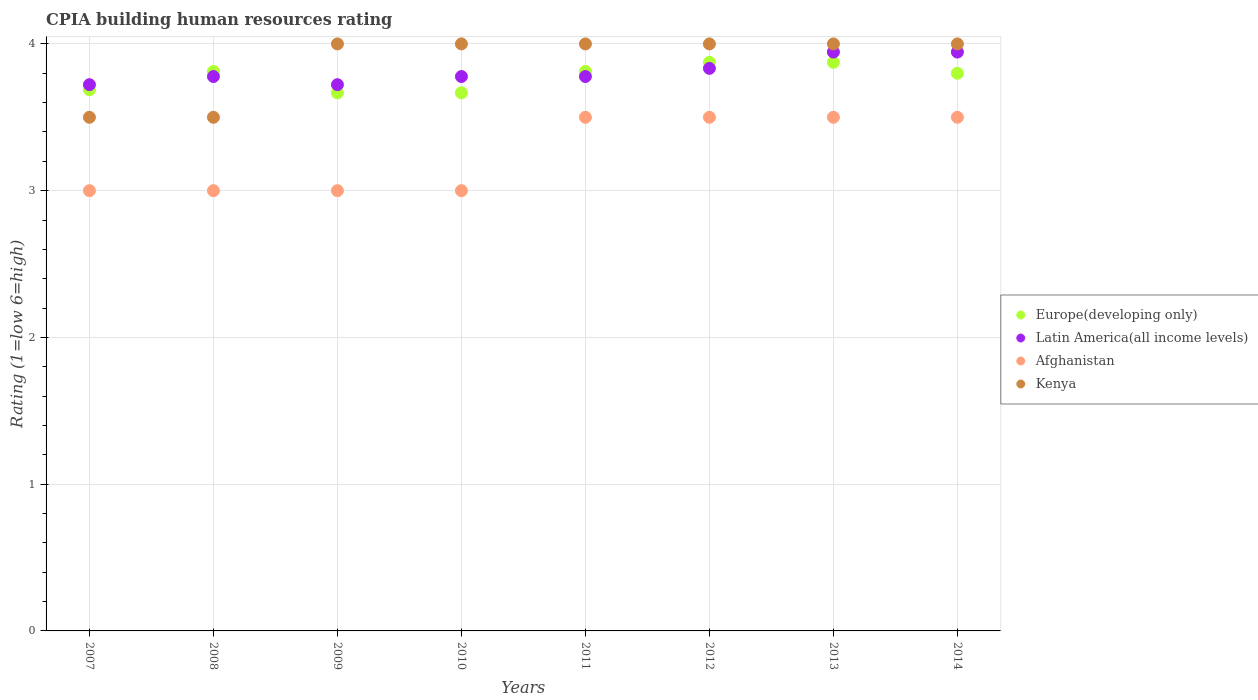Is the number of dotlines equal to the number of legend labels?
Provide a succinct answer. Yes. What is the CPIA rating in Afghanistan in 2010?
Make the answer very short. 3. Across all years, what is the maximum CPIA rating in Latin America(all income levels)?
Your response must be concise. 3.94. Across all years, what is the minimum CPIA rating in Latin America(all income levels)?
Make the answer very short. 3.72. What is the total CPIA rating in Afghanistan in the graph?
Provide a short and direct response. 26. What is the difference between the CPIA rating in Latin America(all income levels) in 2009 and that in 2014?
Give a very brief answer. -0.22. What is the difference between the CPIA rating in Latin America(all income levels) in 2010 and the CPIA rating in Kenya in 2012?
Ensure brevity in your answer.  -0.22. What is the average CPIA rating in Latin America(all income levels) per year?
Your answer should be very brief. 3.81. In the year 2010, what is the difference between the CPIA rating in Latin America(all income levels) and CPIA rating in Kenya?
Make the answer very short. -0.22. In how many years, is the CPIA rating in Europe(developing only) greater than 1.4?
Give a very brief answer. 8. Is the difference between the CPIA rating in Latin America(all income levels) in 2013 and 2014 greater than the difference between the CPIA rating in Kenya in 2013 and 2014?
Ensure brevity in your answer.  No. What is the difference between the highest and the second highest CPIA rating in Kenya?
Your answer should be compact. 0. What is the difference between the highest and the lowest CPIA rating in Kenya?
Your response must be concise. 0.5. Is the sum of the CPIA rating in Europe(developing only) in 2007 and 2013 greater than the maximum CPIA rating in Afghanistan across all years?
Provide a succinct answer. Yes. Is it the case that in every year, the sum of the CPIA rating in Latin America(all income levels) and CPIA rating in Kenya  is greater than the CPIA rating in Europe(developing only)?
Your answer should be compact. Yes. Does the CPIA rating in Europe(developing only) monotonically increase over the years?
Offer a terse response. No. How many dotlines are there?
Make the answer very short. 4. Are the values on the major ticks of Y-axis written in scientific E-notation?
Keep it short and to the point. No. Does the graph contain any zero values?
Your answer should be compact. No. Does the graph contain grids?
Make the answer very short. Yes. How are the legend labels stacked?
Give a very brief answer. Vertical. What is the title of the graph?
Make the answer very short. CPIA building human resources rating. Does "Italy" appear as one of the legend labels in the graph?
Make the answer very short. No. What is the label or title of the X-axis?
Your answer should be very brief. Years. What is the Rating (1=low 6=high) of Europe(developing only) in 2007?
Provide a short and direct response. 3.69. What is the Rating (1=low 6=high) of Latin America(all income levels) in 2007?
Ensure brevity in your answer.  3.72. What is the Rating (1=low 6=high) of Europe(developing only) in 2008?
Ensure brevity in your answer.  3.81. What is the Rating (1=low 6=high) in Latin America(all income levels) in 2008?
Provide a short and direct response. 3.78. What is the Rating (1=low 6=high) in Kenya in 2008?
Ensure brevity in your answer.  3.5. What is the Rating (1=low 6=high) of Europe(developing only) in 2009?
Your answer should be very brief. 3.67. What is the Rating (1=low 6=high) in Latin America(all income levels) in 2009?
Offer a terse response. 3.72. What is the Rating (1=low 6=high) of Afghanistan in 2009?
Make the answer very short. 3. What is the Rating (1=low 6=high) of Europe(developing only) in 2010?
Make the answer very short. 3.67. What is the Rating (1=low 6=high) of Latin America(all income levels) in 2010?
Offer a very short reply. 3.78. What is the Rating (1=low 6=high) in Kenya in 2010?
Offer a terse response. 4. What is the Rating (1=low 6=high) of Europe(developing only) in 2011?
Provide a succinct answer. 3.81. What is the Rating (1=low 6=high) in Latin America(all income levels) in 2011?
Your answer should be very brief. 3.78. What is the Rating (1=low 6=high) in Afghanistan in 2011?
Provide a short and direct response. 3.5. What is the Rating (1=low 6=high) of Kenya in 2011?
Provide a short and direct response. 4. What is the Rating (1=low 6=high) of Europe(developing only) in 2012?
Your answer should be compact. 3.88. What is the Rating (1=low 6=high) of Latin America(all income levels) in 2012?
Your answer should be compact. 3.83. What is the Rating (1=low 6=high) in Afghanistan in 2012?
Ensure brevity in your answer.  3.5. What is the Rating (1=low 6=high) in Europe(developing only) in 2013?
Ensure brevity in your answer.  3.88. What is the Rating (1=low 6=high) of Latin America(all income levels) in 2013?
Keep it short and to the point. 3.94. What is the Rating (1=low 6=high) of Afghanistan in 2013?
Keep it short and to the point. 3.5. What is the Rating (1=low 6=high) in Latin America(all income levels) in 2014?
Provide a short and direct response. 3.94. Across all years, what is the maximum Rating (1=low 6=high) in Europe(developing only)?
Provide a short and direct response. 3.88. Across all years, what is the maximum Rating (1=low 6=high) of Latin America(all income levels)?
Keep it short and to the point. 3.94. Across all years, what is the maximum Rating (1=low 6=high) of Afghanistan?
Ensure brevity in your answer.  3.5. Across all years, what is the minimum Rating (1=low 6=high) in Europe(developing only)?
Keep it short and to the point. 3.67. Across all years, what is the minimum Rating (1=low 6=high) of Latin America(all income levels)?
Provide a short and direct response. 3.72. Across all years, what is the minimum Rating (1=low 6=high) of Afghanistan?
Provide a succinct answer. 3. Across all years, what is the minimum Rating (1=low 6=high) of Kenya?
Keep it short and to the point. 3.5. What is the total Rating (1=low 6=high) in Europe(developing only) in the graph?
Make the answer very short. 30.2. What is the total Rating (1=low 6=high) of Latin America(all income levels) in the graph?
Make the answer very short. 30.5. What is the total Rating (1=low 6=high) of Afghanistan in the graph?
Provide a succinct answer. 26. What is the difference between the Rating (1=low 6=high) of Europe(developing only) in 2007 and that in 2008?
Your answer should be compact. -0.12. What is the difference between the Rating (1=low 6=high) in Latin America(all income levels) in 2007 and that in 2008?
Offer a very short reply. -0.06. What is the difference between the Rating (1=low 6=high) in Afghanistan in 2007 and that in 2008?
Offer a terse response. 0. What is the difference between the Rating (1=low 6=high) of Europe(developing only) in 2007 and that in 2009?
Provide a short and direct response. 0.02. What is the difference between the Rating (1=low 6=high) in Afghanistan in 2007 and that in 2009?
Provide a short and direct response. 0. What is the difference between the Rating (1=low 6=high) in Europe(developing only) in 2007 and that in 2010?
Make the answer very short. 0.02. What is the difference between the Rating (1=low 6=high) in Latin America(all income levels) in 2007 and that in 2010?
Offer a very short reply. -0.06. What is the difference between the Rating (1=low 6=high) of Afghanistan in 2007 and that in 2010?
Your answer should be compact. 0. What is the difference between the Rating (1=low 6=high) of Kenya in 2007 and that in 2010?
Your answer should be compact. -0.5. What is the difference between the Rating (1=low 6=high) in Europe(developing only) in 2007 and that in 2011?
Offer a very short reply. -0.12. What is the difference between the Rating (1=low 6=high) in Latin America(all income levels) in 2007 and that in 2011?
Keep it short and to the point. -0.06. What is the difference between the Rating (1=low 6=high) in Afghanistan in 2007 and that in 2011?
Your response must be concise. -0.5. What is the difference between the Rating (1=low 6=high) of Europe(developing only) in 2007 and that in 2012?
Keep it short and to the point. -0.19. What is the difference between the Rating (1=low 6=high) of Latin America(all income levels) in 2007 and that in 2012?
Your answer should be compact. -0.11. What is the difference between the Rating (1=low 6=high) of Afghanistan in 2007 and that in 2012?
Give a very brief answer. -0.5. What is the difference between the Rating (1=low 6=high) in Europe(developing only) in 2007 and that in 2013?
Keep it short and to the point. -0.19. What is the difference between the Rating (1=low 6=high) of Latin America(all income levels) in 2007 and that in 2013?
Provide a short and direct response. -0.22. What is the difference between the Rating (1=low 6=high) in Afghanistan in 2007 and that in 2013?
Offer a terse response. -0.5. What is the difference between the Rating (1=low 6=high) in Europe(developing only) in 2007 and that in 2014?
Your answer should be very brief. -0.11. What is the difference between the Rating (1=low 6=high) in Latin America(all income levels) in 2007 and that in 2014?
Offer a very short reply. -0.22. What is the difference between the Rating (1=low 6=high) in Afghanistan in 2007 and that in 2014?
Provide a succinct answer. -0.5. What is the difference between the Rating (1=low 6=high) of Kenya in 2007 and that in 2014?
Offer a very short reply. -0.5. What is the difference between the Rating (1=low 6=high) of Europe(developing only) in 2008 and that in 2009?
Your answer should be very brief. 0.15. What is the difference between the Rating (1=low 6=high) of Latin America(all income levels) in 2008 and that in 2009?
Provide a short and direct response. 0.06. What is the difference between the Rating (1=low 6=high) in Kenya in 2008 and that in 2009?
Offer a very short reply. -0.5. What is the difference between the Rating (1=low 6=high) in Europe(developing only) in 2008 and that in 2010?
Ensure brevity in your answer.  0.15. What is the difference between the Rating (1=low 6=high) of Kenya in 2008 and that in 2010?
Provide a short and direct response. -0.5. What is the difference between the Rating (1=low 6=high) in Afghanistan in 2008 and that in 2011?
Keep it short and to the point. -0.5. What is the difference between the Rating (1=low 6=high) of Kenya in 2008 and that in 2011?
Your answer should be very brief. -0.5. What is the difference between the Rating (1=low 6=high) of Europe(developing only) in 2008 and that in 2012?
Offer a very short reply. -0.06. What is the difference between the Rating (1=low 6=high) in Latin America(all income levels) in 2008 and that in 2012?
Keep it short and to the point. -0.06. What is the difference between the Rating (1=low 6=high) of Kenya in 2008 and that in 2012?
Give a very brief answer. -0.5. What is the difference between the Rating (1=low 6=high) of Europe(developing only) in 2008 and that in 2013?
Keep it short and to the point. -0.06. What is the difference between the Rating (1=low 6=high) of Kenya in 2008 and that in 2013?
Keep it short and to the point. -0.5. What is the difference between the Rating (1=low 6=high) in Europe(developing only) in 2008 and that in 2014?
Keep it short and to the point. 0.01. What is the difference between the Rating (1=low 6=high) in Latin America(all income levels) in 2008 and that in 2014?
Your response must be concise. -0.17. What is the difference between the Rating (1=low 6=high) of Kenya in 2008 and that in 2014?
Your answer should be very brief. -0.5. What is the difference between the Rating (1=low 6=high) in Latin America(all income levels) in 2009 and that in 2010?
Offer a terse response. -0.06. What is the difference between the Rating (1=low 6=high) in Afghanistan in 2009 and that in 2010?
Provide a short and direct response. 0. What is the difference between the Rating (1=low 6=high) of Kenya in 2009 and that in 2010?
Give a very brief answer. 0. What is the difference between the Rating (1=low 6=high) in Europe(developing only) in 2009 and that in 2011?
Give a very brief answer. -0.15. What is the difference between the Rating (1=low 6=high) of Latin America(all income levels) in 2009 and that in 2011?
Keep it short and to the point. -0.06. What is the difference between the Rating (1=low 6=high) of Kenya in 2009 and that in 2011?
Provide a short and direct response. 0. What is the difference between the Rating (1=low 6=high) in Europe(developing only) in 2009 and that in 2012?
Your answer should be very brief. -0.21. What is the difference between the Rating (1=low 6=high) of Latin America(all income levels) in 2009 and that in 2012?
Provide a short and direct response. -0.11. What is the difference between the Rating (1=low 6=high) of Afghanistan in 2009 and that in 2012?
Offer a terse response. -0.5. What is the difference between the Rating (1=low 6=high) in Kenya in 2009 and that in 2012?
Provide a succinct answer. 0. What is the difference between the Rating (1=low 6=high) in Europe(developing only) in 2009 and that in 2013?
Offer a terse response. -0.21. What is the difference between the Rating (1=low 6=high) of Latin America(all income levels) in 2009 and that in 2013?
Make the answer very short. -0.22. What is the difference between the Rating (1=low 6=high) in Afghanistan in 2009 and that in 2013?
Keep it short and to the point. -0.5. What is the difference between the Rating (1=low 6=high) of Kenya in 2009 and that in 2013?
Offer a terse response. 0. What is the difference between the Rating (1=low 6=high) of Europe(developing only) in 2009 and that in 2014?
Make the answer very short. -0.13. What is the difference between the Rating (1=low 6=high) in Latin America(all income levels) in 2009 and that in 2014?
Offer a very short reply. -0.22. What is the difference between the Rating (1=low 6=high) in Kenya in 2009 and that in 2014?
Ensure brevity in your answer.  0. What is the difference between the Rating (1=low 6=high) of Europe(developing only) in 2010 and that in 2011?
Make the answer very short. -0.15. What is the difference between the Rating (1=low 6=high) in Latin America(all income levels) in 2010 and that in 2011?
Make the answer very short. 0. What is the difference between the Rating (1=low 6=high) in Afghanistan in 2010 and that in 2011?
Your answer should be very brief. -0.5. What is the difference between the Rating (1=low 6=high) in Europe(developing only) in 2010 and that in 2012?
Offer a very short reply. -0.21. What is the difference between the Rating (1=low 6=high) of Latin America(all income levels) in 2010 and that in 2012?
Ensure brevity in your answer.  -0.06. What is the difference between the Rating (1=low 6=high) of Europe(developing only) in 2010 and that in 2013?
Give a very brief answer. -0.21. What is the difference between the Rating (1=low 6=high) in Latin America(all income levels) in 2010 and that in 2013?
Offer a very short reply. -0.17. What is the difference between the Rating (1=low 6=high) of Afghanistan in 2010 and that in 2013?
Make the answer very short. -0.5. What is the difference between the Rating (1=low 6=high) in Europe(developing only) in 2010 and that in 2014?
Ensure brevity in your answer.  -0.13. What is the difference between the Rating (1=low 6=high) of Kenya in 2010 and that in 2014?
Ensure brevity in your answer.  0. What is the difference between the Rating (1=low 6=high) of Europe(developing only) in 2011 and that in 2012?
Keep it short and to the point. -0.06. What is the difference between the Rating (1=low 6=high) of Latin America(all income levels) in 2011 and that in 2012?
Provide a short and direct response. -0.06. What is the difference between the Rating (1=low 6=high) of Kenya in 2011 and that in 2012?
Give a very brief answer. 0. What is the difference between the Rating (1=low 6=high) in Europe(developing only) in 2011 and that in 2013?
Provide a succinct answer. -0.06. What is the difference between the Rating (1=low 6=high) of Afghanistan in 2011 and that in 2013?
Make the answer very short. 0. What is the difference between the Rating (1=low 6=high) of Kenya in 2011 and that in 2013?
Make the answer very short. 0. What is the difference between the Rating (1=low 6=high) in Europe(developing only) in 2011 and that in 2014?
Provide a succinct answer. 0.01. What is the difference between the Rating (1=low 6=high) of Kenya in 2011 and that in 2014?
Your answer should be compact. 0. What is the difference between the Rating (1=low 6=high) in Europe(developing only) in 2012 and that in 2013?
Ensure brevity in your answer.  0. What is the difference between the Rating (1=low 6=high) in Latin America(all income levels) in 2012 and that in 2013?
Provide a short and direct response. -0.11. What is the difference between the Rating (1=low 6=high) in Afghanistan in 2012 and that in 2013?
Keep it short and to the point. 0. What is the difference between the Rating (1=low 6=high) of Kenya in 2012 and that in 2013?
Offer a terse response. 0. What is the difference between the Rating (1=low 6=high) of Europe(developing only) in 2012 and that in 2014?
Ensure brevity in your answer.  0.07. What is the difference between the Rating (1=low 6=high) of Latin America(all income levels) in 2012 and that in 2014?
Keep it short and to the point. -0.11. What is the difference between the Rating (1=low 6=high) of Afghanistan in 2012 and that in 2014?
Make the answer very short. 0. What is the difference between the Rating (1=low 6=high) of Europe(developing only) in 2013 and that in 2014?
Offer a very short reply. 0.07. What is the difference between the Rating (1=low 6=high) in Afghanistan in 2013 and that in 2014?
Offer a terse response. 0. What is the difference between the Rating (1=low 6=high) of Kenya in 2013 and that in 2014?
Offer a very short reply. 0. What is the difference between the Rating (1=low 6=high) in Europe(developing only) in 2007 and the Rating (1=low 6=high) in Latin America(all income levels) in 2008?
Provide a succinct answer. -0.09. What is the difference between the Rating (1=low 6=high) in Europe(developing only) in 2007 and the Rating (1=low 6=high) in Afghanistan in 2008?
Make the answer very short. 0.69. What is the difference between the Rating (1=low 6=high) in Europe(developing only) in 2007 and the Rating (1=low 6=high) in Kenya in 2008?
Your answer should be very brief. 0.19. What is the difference between the Rating (1=low 6=high) of Latin America(all income levels) in 2007 and the Rating (1=low 6=high) of Afghanistan in 2008?
Offer a very short reply. 0.72. What is the difference between the Rating (1=low 6=high) of Latin America(all income levels) in 2007 and the Rating (1=low 6=high) of Kenya in 2008?
Give a very brief answer. 0.22. What is the difference between the Rating (1=low 6=high) of Europe(developing only) in 2007 and the Rating (1=low 6=high) of Latin America(all income levels) in 2009?
Offer a very short reply. -0.03. What is the difference between the Rating (1=low 6=high) in Europe(developing only) in 2007 and the Rating (1=low 6=high) in Afghanistan in 2009?
Provide a short and direct response. 0.69. What is the difference between the Rating (1=low 6=high) of Europe(developing only) in 2007 and the Rating (1=low 6=high) of Kenya in 2009?
Keep it short and to the point. -0.31. What is the difference between the Rating (1=low 6=high) in Latin America(all income levels) in 2007 and the Rating (1=low 6=high) in Afghanistan in 2009?
Keep it short and to the point. 0.72. What is the difference between the Rating (1=low 6=high) of Latin America(all income levels) in 2007 and the Rating (1=low 6=high) of Kenya in 2009?
Provide a succinct answer. -0.28. What is the difference between the Rating (1=low 6=high) in Europe(developing only) in 2007 and the Rating (1=low 6=high) in Latin America(all income levels) in 2010?
Your answer should be compact. -0.09. What is the difference between the Rating (1=low 6=high) in Europe(developing only) in 2007 and the Rating (1=low 6=high) in Afghanistan in 2010?
Offer a terse response. 0.69. What is the difference between the Rating (1=low 6=high) of Europe(developing only) in 2007 and the Rating (1=low 6=high) of Kenya in 2010?
Your answer should be very brief. -0.31. What is the difference between the Rating (1=low 6=high) of Latin America(all income levels) in 2007 and the Rating (1=low 6=high) of Afghanistan in 2010?
Provide a short and direct response. 0.72. What is the difference between the Rating (1=low 6=high) of Latin America(all income levels) in 2007 and the Rating (1=low 6=high) of Kenya in 2010?
Keep it short and to the point. -0.28. What is the difference between the Rating (1=low 6=high) in Afghanistan in 2007 and the Rating (1=low 6=high) in Kenya in 2010?
Offer a terse response. -1. What is the difference between the Rating (1=low 6=high) of Europe(developing only) in 2007 and the Rating (1=low 6=high) of Latin America(all income levels) in 2011?
Keep it short and to the point. -0.09. What is the difference between the Rating (1=low 6=high) of Europe(developing only) in 2007 and the Rating (1=low 6=high) of Afghanistan in 2011?
Provide a succinct answer. 0.19. What is the difference between the Rating (1=low 6=high) in Europe(developing only) in 2007 and the Rating (1=low 6=high) in Kenya in 2011?
Give a very brief answer. -0.31. What is the difference between the Rating (1=low 6=high) of Latin America(all income levels) in 2007 and the Rating (1=low 6=high) of Afghanistan in 2011?
Ensure brevity in your answer.  0.22. What is the difference between the Rating (1=low 6=high) in Latin America(all income levels) in 2007 and the Rating (1=low 6=high) in Kenya in 2011?
Give a very brief answer. -0.28. What is the difference between the Rating (1=low 6=high) in Europe(developing only) in 2007 and the Rating (1=low 6=high) in Latin America(all income levels) in 2012?
Your answer should be compact. -0.15. What is the difference between the Rating (1=low 6=high) of Europe(developing only) in 2007 and the Rating (1=low 6=high) of Afghanistan in 2012?
Offer a very short reply. 0.19. What is the difference between the Rating (1=low 6=high) in Europe(developing only) in 2007 and the Rating (1=low 6=high) in Kenya in 2012?
Your response must be concise. -0.31. What is the difference between the Rating (1=low 6=high) in Latin America(all income levels) in 2007 and the Rating (1=low 6=high) in Afghanistan in 2012?
Your response must be concise. 0.22. What is the difference between the Rating (1=low 6=high) of Latin America(all income levels) in 2007 and the Rating (1=low 6=high) of Kenya in 2012?
Your response must be concise. -0.28. What is the difference between the Rating (1=low 6=high) of Afghanistan in 2007 and the Rating (1=low 6=high) of Kenya in 2012?
Offer a very short reply. -1. What is the difference between the Rating (1=low 6=high) of Europe(developing only) in 2007 and the Rating (1=low 6=high) of Latin America(all income levels) in 2013?
Provide a short and direct response. -0.26. What is the difference between the Rating (1=low 6=high) in Europe(developing only) in 2007 and the Rating (1=low 6=high) in Afghanistan in 2013?
Offer a very short reply. 0.19. What is the difference between the Rating (1=low 6=high) in Europe(developing only) in 2007 and the Rating (1=low 6=high) in Kenya in 2013?
Your response must be concise. -0.31. What is the difference between the Rating (1=low 6=high) in Latin America(all income levels) in 2007 and the Rating (1=low 6=high) in Afghanistan in 2013?
Provide a short and direct response. 0.22. What is the difference between the Rating (1=low 6=high) in Latin America(all income levels) in 2007 and the Rating (1=low 6=high) in Kenya in 2013?
Keep it short and to the point. -0.28. What is the difference between the Rating (1=low 6=high) of Europe(developing only) in 2007 and the Rating (1=low 6=high) of Latin America(all income levels) in 2014?
Provide a short and direct response. -0.26. What is the difference between the Rating (1=low 6=high) in Europe(developing only) in 2007 and the Rating (1=low 6=high) in Afghanistan in 2014?
Provide a succinct answer. 0.19. What is the difference between the Rating (1=low 6=high) in Europe(developing only) in 2007 and the Rating (1=low 6=high) in Kenya in 2014?
Your answer should be very brief. -0.31. What is the difference between the Rating (1=low 6=high) in Latin America(all income levels) in 2007 and the Rating (1=low 6=high) in Afghanistan in 2014?
Make the answer very short. 0.22. What is the difference between the Rating (1=low 6=high) in Latin America(all income levels) in 2007 and the Rating (1=low 6=high) in Kenya in 2014?
Make the answer very short. -0.28. What is the difference between the Rating (1=low 6=high) in Europe(developing only) in 2008 and the Rating (1=low 6=high) in Latin America(all income levels) in 2009?
Make the answer very short. 0.09. What is the difference between the Rating (1=low 6=high) in Europe(developing only) in 2008 and the Rating (1=low 6=high) in Afghanistan in 2009?
Make the answer very short. 0.81. What is the difference between the Rating (1=low 6=high) of Europe(developing only) in 2008 and the Rating (1=low 6=high) of Kenya in 2009?
Your response must be concise. -0.19. What is the difference between the Rating (1=low 6=high) of Latin America(all income levels) in 2008 and the Rating (1=low 6=high) of Afghanistan in 2009?
Provide a short and direct response. 0.78. What is the difference between the Rating (1=low 6=high) of Latin America(all income levels) in 2008 and the Rating (1=low 6=high) of Kenya in 2009?
Give a very brief answer. -0.22. What is the difference between the Rating (1=low 6=high) of Afghanistan in 2008 and the Rating (1=low 6=high) of Kenya in 2009?
Give a very brief answer. -1. What is the difference between the Rating (1=low 6=high) in Europe(developing only) in 2008 and the Rating (1=low 6=high) in Latin America(all income levels) in 2010?
Your answer should be compact. 0.03. What is the difference between the Rating (1=low 6=high) in Europe(developing only) in 2008 and the Rating (1=low 6=high) in Afghanistan in 2010?
Provide a short and direct response. 0.81. What is the difference between the Rating (1=low 6=high) in Europe(developing only) in 2008 and the Rating (1=low 6=high) in Kenya in 2010?
Your response must be concise. -0.19. What is the difference between the Rating (1=low 6=high) in Latin America(all income levels) in 2008 and the Rating (1=low 6=high) in Afghanistan in 2010?
Give a very brief answer. 0.78. What is the difference between the Rating (1=low 6=high) of Latin America(all income levels) in 2008 and the Rating (1=low 6=high) of Kenya in 2010?
Your answer should be compact. -0.22. What is the difference between the Rating (1=low 6=high) in Europe(developing only) in 2008 and the Rating (1=low 6=high) in Latin America(all income levels) in 2011?
Give a very brief answer. 0.03. What is the difference between the Rating (1=low 6=high) in Europe(developing only) in 2008 and the Rating (1=low 6=high) in Afghanistan in 2011?
Provide a short and direct response. 0.31. What is the difference between the Rating (1=low 6=high) of Europe(developing only) in 2008 and the Rating (1=low 6=high) of Kenya in 2011?
Keep it short and to the point. -0.19. What is the difference between the Rating (1=low 6=high) of Latin America(all income levels) in 2008 and the Rating (1=low 6=high) of Afghanistan in 2011?
Give a very brief answer. 0.28. What is the difference between the Rating (1=low 6=high) in Latin America(all income levels) in 2008 and the Rating (1=low 6=high) in Kenya in 2011?
Ensure brevity in your answer.  -0.22. What is the difference between the Rating (1=low 6=high) in Afghanistan in 2008 and the Rating (1=low 6=high) in Kenya in 2011?
Provide a succinct answer. -1. What is the difference between the Rating (1=low 6=high) of Europe(developing only) in 2008 and the Rating (1=low 6=high) of Latin America(all income levels) in 2012?
Provide a succinct answer. -0.02. What is the difference between the Rating (1=low 6=high) in Europe(developing only) in 2008 and the Rating (1=low 6=high) in Afghanistan in 2012?
Your answer should be compact. 0.31. What is the difference between the Rating (1=low 6=high) in Europe(developing only) in 2008 and the Rating (1=low 6=high) in Kenya in 2012?
Your answer should be very brief. -0.19. What is the difference between the Rating (1=low 6=high) of Latin America(all income levels) in 2008 and the Rating (1=low 6=high) of Afghanistan in 2012?
Make the answer very short. 0.28. What is the difference between the Rating (1=low 6=high) in Latin America(all income levels) in 2008 and the Rating (1=low 6=high) in Kenya in 2012?
Keep it short and to the point. -0.22. What is the difference between the Rating (1=low 6=high) of Afghanistan in 2008 and the Rating (1=low 6=high) of Kenya in 2012?
Make the answer very short. -1. What is the difference between the Rating (1=low 6=high) in Europe(developing only) in 2008 and the Rating (1=low 6=high) in Latin America(all income levels) in 2013?
Your answer should be compact. -0.13. What is the difference between the Rating (1=low 6=high) of Europe(developing only) in 2008 and the Rating (1=low 6=high) of Afghanistan in 2013?
Your answer should be compact. 0.31. What is the difference between the Rating (1=low 6=high) in Europe(developing only) in 2008 and the Rating (1=low 6=high) in Kenya in 2013?
Provide a succinct answer. -0.19. What is the difference between the Rating (1=low 6=high) in Latin America(all income levels) in 2008 and the Rating (1=low 6=high) in Afghanistan in 2013?
Your answer should be very brief. 0.28. What is the difference between the Rating (1=low 6=high) of Latin America(all income levels) in 2008 and the Rating (1=low 6=high) of Kenya in 2013?
Offer a terse response. -0.22. What is the difference between the Rating (1=low 6=high) of Afghanistan in 2008 and the Rating (1=low 6=high) of Kenya in 2013?
Give a very brief answer. -1. What is the difference between the Rating (1=low 6=high) in Europe(developing only) in 2008 and the Rating (1=low 6=high) in Latin America(all income levels) in 2014?
Your answer should be compact. -0.13. What is the difference between the Rating (1=low 6=high) of Europe(developing only) in 2008 and the Rating (1=low 6=high) of Afghanistan in 2014?
Keep it short and to the point. 0.31. What is the difference between the Rating (1=low 6=high) of Europe(developing only) in 2008 and the Rating (1=low 6=high) of Kenya in 2014?
Ensure brevity in your answer.  -0.19. What is the difference between the Rating (1=low 6=high) in Latin America(all income levels) in 2008 and the Rating (1=low 6=high) in Afghanistan in 2014?
Provide a succinct answer. 0.28. What is the difference between the Rating (1=low 6=high) of Latin America(all income levels) in 2008 and the Rating (1=low 6=high) of Kenya in 2014?
Keep it short and to the point. -0.22. What is the difference between the Rating (1=low 6=high) in Europe(developing only) in 2009 and the Rating (1=low 6=high) in Latin America(all income levels) in 2010?
Make the answer very short. -0.11. What is the difference between the Rating (1=low 6=high) in Latin America(all income levels) in 2009 and the Rating (1=low 6=high) in Afghanistan in 2010?
Offer a terse response. 0.72. What is the difference between the Rating (1=low 6=high) of Latin America(all income levels) in 2009 and the Rating (1=low 6=high) of Kenya in 2010?
Ensure brevity in your answer.  -0.28. What is the difference between the Rating (1=low 6=high) of Europe(developing only) in 2009 and the Rating (1=low 6=high) of Latin America(all income levels) in 2011?
Your answer should be compact. -0.11. What is the difference between the Rating (1=low 6=high) of Europe(developing only) in 2009 and the Rating (1=low 6=high) of Afghanistan in 2011?
Your answer should be very brief. 0.17. What is the difference between the Rating (1=low 6=high) of Latin America(all income levels) in 2009 and the Rating (1=low 6=high) of Afghanistan in 2011?
Your answer should be very brief. 0.22. What is the difference between the Rating (1=low 6=high) in Latin America(all income levels) in 2009 and the Rating (1=low 6=high) in Kenya in 2011?
Keep it short and to the point. -0.28. What is the difference between the Rating (1=low 6=high) of Europe(developing only) in 2009 and the Rating (1=low 6=high) of Latin America(all income levels) in 2012?
Provide a short and direct response. -0.17. What is the difference between the Rating (1=low 6=high) of Europe(developing only) in 2009 and the Rating (1=low 6=high) of Kenya in 2012?
Keep it short and to the point. -0.33. What is the difference between the Rating (1=low 6=high) in Latin America(all income levels) in 2009 and the Rating (1=low 6=high) in Afghanistan in 2012?
Provide a short and direct response. 0.22. What is the difference between the Rating (1=low 6=high) of Latin America(all income levels) in 2009 and the Rating (1=low 6=high) of Kenya in 2012?
Give a very brief answer. -0.28. What is the difference between the Rating (1=low 6=high) in Afghanistan in 2009 and the Rating (1=low 6=high) in Kenya in 2012?
Offer a terse response. -1. What is the difference between the Rating (1=low 6=high) of Europe(developing only) in 2009 and the Rating (1=low 6=high) of Latin America(all income levels) in 2013?
Provide a short and direct response. -0.28. What is the difference between the Rating (1=low 6=high) in Europe(developing only) in 2009 and the Rating (1=low 6=high) in Kenya in 2013?
Your response must be concise. -0.33. What is the difference between the Rating (1=low 6=high) of Latin America(all income levels) in 2009 and the Rating (1=low 6=high) of Afghanistan in 2013?
Provide a short and direct response. 0.22. What is the difference between the Rating (1=low 6=high) in Latin America(all income levels) in 2009 and the Rating (1=low 6=high) in Kenya in 2013?
Provide a short and direct response. -0.28. What is the difference between the Rating (1=low 6=high) of Afghanistan in 2009 and the Rating (1=low 6=high) of Kenya in 2013?
Provide a succinct answer. -1. What is the difference between the Rating (1=low 6=high) of Europe(developing only) in 2009 and the Rating (1=low 6=high) of Latin America(all income levels) in 2014?
Give a very brief answer. -0.28. What is the difference between the Rating (1=low 6=high) of Latin America(all income levels) in 2009 and the Rating (1=low 6=high) of Afghanistan in 2014?
Provide a short and direct response. 0.22. What is the difference between the Rating (1=low 6=high) in Latin America(all income levels) in 2009 and the Rating (1=low 6=high) in Kenya in 2014?
Offer a very short reply. -0.28. What is the difference between the Rating (1=low 6=high) of Afghanistan in 2009 and the Rating (1=low 6=high) of Kenya in 2014?
Your response must be concise. -1. What is the difference between the Rating (1=low 6=high) of Europe(developing only) in 2010 and the Rating (1=low 6=high) of Latin America(all income levels) in 2011?
Make the answer very short. -0.11. What is the difference between the Rating (1=low 6=high) of Europe(developing only) in 2010 and the Rating (1=low 6=high) of Afghanistan in 2011?
Make the answer very short. 0.17. What is the difference between the Rating (1=low 6=high) in Latin America(all income levels) in 2010 and the Rating (1=low 6=high) in Afghanistan in 2011?
Offer a terse response. 0.28. What is the difference between the Rating (1=low 6=high) in Latin America(all income levels) in 2010 and the Rating (1=low 6=high) in Kenya in 2011?
Provide a short and direct response. -0.22. What is the difference between the Rating (1=low 6=high) in Afghanistan in 2010 and the Rating (1=low 6=high) in Kenya in 2011?
Offer a very short reply. -1. What is the difference between the Rating (1=low 6=high) of Europe(developing only) in 2010 and the Rating (1=low 6=high) of Kenya in 2012?
Offer a very short reply. -0.33. What is the difference between the Rating (1=low 6=high) in Latin America(all income levels) in 2010 and the Rating (1=low 6=high) in Afghanistan in 2012?
Provide a succinct answer. 0.28. What is the difference between the Rating (1=low 6=high) in Latin America(all income levels) in 2010 and the Rating (1=low 6=high) in Kenya in 2012?
Offer a very short reply. -0.22. What is the difference between the Rating (1=low 6=high) in Afghanistan in 2010 and the Rating (1=low 6=high) in Kenya in 2012?
Offer a very short reply. -1. What is the difference between the Rating (1=low 6=high) in Europe(developing only) in 2010 and the Rating (1=low 6=high) in Latin America(all income levels) in 2013?
Give a very brief answer. -0.28. What is the difference between the Rating (1=low 6=high) in Latin America(all income levels) in 2010 and the Rating (1=low 6=high) in Afghanistan in 2013?
Provide a succinct answer. 0.28. What is the difference between the Rating (1=low 6=high) of Latin America(all income levels) in 2010 and the Rating (1=low 6=high) of Kenya in 2013?
Offer a terse response. -0.22. What is the difference between the Rating (1=low 6=high) of Afghanistan in 2010 and the Rating (1=low 6=high) of Kenya in 2013?
Ensure brevity in your answer.  -1. What is the difference between the Rating (1=low 6=high) of Europe(developing only) in 2010 and the Rating (1=low 6=high) of Latin America(all income levels) in 2014?
Your answer should be very brief. -0.28. What is the difference between the Rating (1=low 6=high) in Europe(developing only) in 2010 and the Rating (1=low 6=high) in Afghanistan in 2014?
Provide a succinct answer. 0.17. What is the difference between the Rating (1=low 6=high) of Europe(developing only) in 2010 and the Rating (1=low 6=high) of Kenya in 2014?
Give a very brief answer. -0.33. What is the difference between the Rating (1=low 6=high) of Latin America(all income levels) in 2010 and the Rating (1=low 6=high) of Afghanistan in 2014?
Offer a terse response. 0.28. What is the difference between the Rating (1=low 6=high) in Latin America(all income levels) in 2010 and the Rating (1=low 6=high) in Kenya in 2014?
Make the answer very short. -0.22. What is the difference between the Rating (1=low 6=high) of Afghanistan in 2010 and the Rating (1=low 6=high) of Kenya in 2014?
Offer a terse response. -1. What is the difference between the Rating (1=low 6=high) of Europe(developing only) in 2011 and the Rating (1=low 6=high) of Latin America(all income levels) in 2012?
Provide a succinct answer. -0.02. What is the difference between the Rating (1=low 6=high) of Europe(developing only) in 2011 and the Rating (1=low 6=high) of Afghanistan in 2012?
Your answer should be very brief. 0.31. What is the difference between the Rating (1=low 6=high) of Europe(developing only) in 2011 and the Rating (1=low 6=high) of Kenya in 2012?
Provide a short and direct response. -0.19. What is the difference between the Rating (1=low 6=high) in Latin America(all income levels) in 2011 and the Rating (1=low 6=high) in Afghanistan in 2012?
Your answer should be very brief. 0.28. What is the difference between the Rating (1=low 6=high) in Latin America(all income levels) in 2011 and the Rating (1=low 6=high) in Kenya in 2012?
Offer a very short reply. -0.22. What is the difference between the Rating (1=low 6=high) of Europe(developing only) in 2011 and the Rating (1=low 6=high) of Latin America(all income levels) in 2013?
Keep it short and to the point. -0.13. What is the difference between the Rating (1=low 6=high) in Europe(developing only) in 2011 and the Rating (1=low 6=high) in Afghanistan in 2013?
Ensure brevity in your answer.  0.31. What is the difference between the Rating (1=low 6=high) in Europe(developing only) in 2011 and the Rating (1=low 6=high) in Kenya in 2013?
Provide a short and direct response. -0.19. What is the difference between the Rating (1=low 6=high) in Latin America(all income levels) in 2011 and the Rating (1=low 6=high) in Afghanistan in 2013?
Ensure brevity in your answer.  0.28. What is the difference between the Rating (1=low 6=high) in Latin America(all income levels) in 2011 and the Rating (1=low 6=high) in Kenya in 2013?
Keep it short and to the point. -0.22. What is the difference between the Rating (1=low 6=high) in Afghanistan in 2011 and the Rating (1=low 6=high) in Kenya in 2013?
Offer a terse response. -0.5. What is the difference between the Rating (1=low 6=high) in Europe(developing only) in 2011 and the Rating (1=low 6=high) in Latin America(all income levels) in 2014?
Offer a very short reply. -0.13. What is the difference between the Rating (1=low 6=high) of Europe(developing only) in 2011 and the Rating (1=low 6=high) of Afghanistan in 2014?
Offer a terse response. 0.31. What is the difference between the Rating (1=low 6=high) in Europe(developing only) in 2011 and the Rating (1=low 6=high) in Kenya in 2014?
Offer a very short reply. -0.19. What is the difference between the Rating (1=low 6=high) in Latin America(all income levels) in 2011 and the Rating (1=low 6=high) in Afghanistan in 2014?
Keep it short and to the point. 0.28. What is the difference between the Rating (1=low 6=high) in Latin America(all income levels) in 2011 and the Rating (1=low 6=high) in Kenya in 2014?
Your answer should be very brief. -0.22. What is the difference between the Rating (1=low 6=high) of Afghanistan in 2011 and the Rating (1=low 6=high) of Kenya in 2014?
Give a very brief answer. -0.5. What is the difference between the Rating (1=low 6=high) in Europe(developing only) in 2012 and the Rating (1=low 6=high) in Latin America(all income levels) in 2013?
Provide a short and direct response. -0.07. What is the difference between the Rating (1=low 6=high) in Europe(developing only) in 2012 and the Rating (1=low 6=high) in Kenya in 2013?
Your response must be concise. -0.12. What is the difference between the Rating (1=low 6=high) in Latin America(all income levels) in 2012 and the Rating (1=low 6=high) in Kenya in 2013?
Provide a succinct answer. -0.17. What is the difference between the Rating (1=low 6=high) in Europe(developing only) in 2012 and the Rating (1=low 6=high) in Latin America(all income levels) in 2014?
Your answer should be very brief. -0.07. What is the difference between the Rating (1=low 6=high) of Europe(developing only) in 2012 and the Rating (1=low 6=high) of Kenya in 2014?
Ensure brevity in your answer.  -0.12. What is the difference between the Rating (1=low 6=high) of Latin America(all income levels) in 2012 and the Rating (1=low 6=high) of Afghanistan in 2014?
Provide a short and direct response. 0.33. What is the difference between the Rating (1=low 6=high) in Afghanistan in 2012 and the Rating (1=low 6=high) in Kenya in 2014?
Provide a succinct answer. -0.5. What is the difference between the Rating (1=low 6=high) in Europe(developing only) in 2013 and the Rating (1=low 6=high) in Latin America(all income levels) in 2014?
Keep it short and to the point. -0.07. What is the difference between the Rating (1=low 6=high) in Europe(developing only) in 2013 and the Rating (1=low 6=high) in Afghanistan in 2014?
Offer a very short reply. 0.38. What is the difference between the Rating (1=low 6=high) in Europe(developing only) in 2013 and the Rating (1=low 6=high) in Kenya in 2014?
Provide a short and direct response. -0.12. What is the difference between the Rating (1=low 6=high) in Latin America(all income levels) in 2013 and the Rating (1=low 6=high) in Afghanistan in 2014?
Keep it short and to the point. 0.44. What is the difference between the Rating (1=low 6=high) in Latin America(all income levels) in 2013 and the Rating (1=low 6=high) in Kenya in 2014?
Keep it short and to the point. -0.06. What is the difference between the Rating (1=low 6=high) in Afghanistan in 2013 and the Rating (1=low 6=high) in Kenya in 2014?
Offer a terse response. -0.5. What is the average Rating (1=low 6=high) of Europe(developing only) per year?
Provide a succinct answer. 3.77. What is the average Rating (1=low 6=high) of Latin America(all income levels) per year?
Your response must be concise. 3.81. What is the average Rating (1=low 6=high) in Kenya per year?
Ensure brevity in your answer.  3.88. In the year 2007, what is the difference between the Rating (1=low 6=high) in Europe(developing only) and Rating (1=low 6=high) in Latin America(all income levels)?
Give a very brief answer. -0.03. In the year 2007, what is the difference between the Rating (1=low 6=high) in Europe(developing only) and Rating (1=low 6=high) in Afghanistan?
Make the answer very short. 0.69. In the year 2007, what is the difference between the Rating (1=low 6=high) in Europe(developing only) and Rating (1=low 6=high) in Kenya?
Provide a short and direct response. 0.19. In the year 2007, what is the difference between the Rating (1=low 6=high) in Latin America(all income levels) and Rating (1=low 6=high) in Afghanistan?
Ensure brevity in your answer.  0.72. In the year 2007, what is the difference between the Rating (1=low 6=high) in Latin America(all income levels) and Rating (1=low 6=high) in Kenya?
Make the answer very short. 0.22. In the year 2008, what is the difference between the Rating (1=low 6=high) in Europe(developing only) and Rating (1=low 6=high) in Latin America(all income levels)?
Your response must be concise. 0.03. In the year 2008, what is the difference between the Rating (1=low 6=high) of Europe(developing only) and Rating (1=low 6=high) of Afghanistan?
Offer a terse response. 0.81. In the year 2008, what is the difference between the Rating (1=low 6=high) in Europe(developing only) and Rating (1=low 6=high) in Kenya?
Your response must be concise. 0.31. In the year 2008, what is the difference between the Rating (1=low 6=high) in Latin America(all income levels) and Rating (1=low 6=high) in Afghanistan?
Your response must be concise. 0.78. In the year 2008, what is the difference between the Rating (1=low 6=high) of Latin America(all income levels) and Rating (1=low 6=high) of Kenya?
Keep it short and to the point. 0.28. In the year 2008, what is the difference between the Rating (1=low 6=high) of Afghanistan and Rating (1=low 6=high) of Kenya?
Offer a very short reply. -0.5. In the year 2009, what is the difference between the Rating (1=low 6=high) of Europe(developing only) and Rating (1=low 6=high) of Latin America(all income levels)?
Provide a succinct answer. -0.06. In the year 2009, what is the difference between the Rating (1=low 6=high) of Europe(developing only) and Rating (1=low 6=high) of Kenya?
Your answer should be compact. -0.33. In the year 2009, what is the difference between the Rating (1=low 6=high) in Latin America(all income levels) and Rating (1=low 6=high) in Afghanistan?
Your answer should be compact. 0.72. In the year 2009, what is the difference between the Rating (1=low 6=high) of Latin America(all income levels) and Rating (1=low 6=high) of Kenya?
Make the answer very short. -0.28. In the year 2010, what is the difference between the Rating (1=low 6=high) of Europe(developing only) and Rating (1=low 6=high) of Latin America(all income levels)?
Ensure brevity in your answer.  -0.11. In the year 2010, what is the difference between the Rating (1=low 6=high) of Europe(developing only) and Rating (1=low 6=high) of Kenya?
Provide a short and direct response. -0.33. In the year 2010, what is the difference between the Rating (1=low 6=high) in Latin America(all income levels) and Rating (1=low 6=high) in Afghanistan?
Ensure brevity in your answer.  0.78. In the year 2010, what is the difference between the Rating (1=low 6=high) of Latin America(all income levels) and Rating (1=low 6=high) of Kenya?
Offer a very short reply. -0.22. In the year 2010, what is the difference between the Rating (1=low 6=high) of Afghanistan and Rating (1=low 6=high) of Kenya?
Keep it short and to the point. -1. In the year 2011, what is the difference between the Rating (1=low 6=high) in Europe(developing only) and Rating (1=low 6=high) in Latin America(all income levels)?
Give a very brief answer. 0.03. In the year 2011, what is the difference between the Rating (1=low 6=high) of Europe(developing only) and Rating (1=low 6=high) of Afghanistan?
Offer a terse response. 0.31. In the year 2011, what is the difference between the Rating (1=low 6=high) in Europe(developing only) and Rating (1=low 6=high) in Kenya?
Offer a very short reply. -0.19. In the year 2011, what is the difference between the Rating (1=low 6=high) of Latin America(all income levels) and Rating (1=low 6=high) of Afghanistan?
Offer a terse response. 0.28. In the year 2011, what is the difference between the Rating (1=low 6=high) of Latin America(all income levels) and Rating (1=low 6=high) of Kenya?
Keep it short and to the point. -0.22. In the year 2011, what is the difference between the Rating (1=low 6=high) in Afghanistan and Rating (1=low 6=high) in Kenya?
Your answer should be very brief. -0.5. In the year 2012, what is the difference between the Rating (1=low 6=high) of Europe(developing only) and Rating (1=low 6=high) of Latin America(all income levels)?
Give a very brief answer. 0.04. In the year 2012, what is the difference between the Rating (1=low 6=high) of Europe(developing only) and Rating (1=low 6=high) of Afghanistan?
Give a very brief answer. 0.38. In the year 2012, what is the difference between the Rating (1=low 6=high) of Europe(developing only) and Rating (1=low 6=high) of Kenya?
Provide a short and direct response. -0.12. In the year 2012, what is the difference between the Rating (1=low 6=high) in Latin America(all income levels) and Rating (1=low 6=high) in Kenya?
Make the answer very short. -0.17. In the year 2013, what is the difference between the Rating (1=low 6=high) of Europe(developing only) and Rating (1=low 6=high) of Latin America(all income levels)?
Your answer should be very brief. -0.07. In the year 2013, what is the difference between the Rating (1=low 6=high) in Europe(developing only) and Rating (1=low 6=high) in Afghanistan?
Make the answer very short. 0.38. In the year 2013, what is the difference between the Rating (1=low 6=high) in Europe(developing only) and Rating (1=low 6=high) in Kenya?
Offer a terse response. -0.12. In the year 2013, what is the difference between the Rating (1=low 6=high) in Latin America(all income levels) and Rating (1=low 6=high) in Afghanistan?
Offer a terse response. 0.44. In the year 2013, what is the difference between the Rating (1=low 6=high) in Latin America(all income levels) and Rating (1=low 6=high) in Kenya?
Your answer should be very brief. -0.06. In the year 2013, what is the difference between the Rating (1=low 6=high) of Afghanistan and Rating (1=low 6=high) of Kenya?
Keep it short and to the point. -0.5. In the year 2014, what is the difference between the Rating (1=low 6=high) in Europe(developing only) and Rating (1=low 6=high) in Latin America(all income levels)?
Your response must be concise. -0.14. In the year 2014, what is the difference between the Rating (1=low 6=high) of Europe(developing only) and Rating (1=low 6=high) of Kenya?
Your answer should be compact. -0.2. In the year 2014, what is the difference between the Rating (1=low 6=high) of Latin America(all income levels) and Rating (1=low 6=high) of Afghanistan?
Your response must be concise. 0.44. In the year 2014, what is the difference between the Rating (1=low 6=high) of Latin America(all income levels) and Rating (1=low 6=high) of Kenya?
Your response must be concise. -0.06. In the year 2014, what is the difference between the Rating (1=low 6=high) of Afghanistan and Rating (1=low 6=high) of Kenya?
Ensure brevity in your answer.  -0.5. What is the ratio of the Rating (1=low 6=high) of Europe(developing only) in 2007 to that in 2008?
Your answer should be very brief. 0.97. What is the ratio of the Rating (1=low 6=high) in Kenya in 2007 to that in 2008?
Offer a terse response. 1. What is the ratio of the Rating (1=low 6=high) in Europe(developing only) in 2007 to that in 2009?
Provide a short and direct response. 1.01. What is the ratio of the Rating (1=low 6=high) in Kenya in 2007 to that in 2009?
Provide a succinct answer. 0.88. What is the ratio of the Rating (1=low 6=high) of Latin America(all income levels) in 2007 to that in 2010?
Provide a short and direct response. 0.99. What is the ratio of the Rating (1=low 6=high) in Afghanistan in 2007 to that in 2010?
Your answer should be compact. 1. What is the ratio of the Rating (1=low 6=high) of Kenya in 2007 to that in 2010?
Keep it short and to the point. 0.88. What is the ratio of the Rating (1=low 6=high) in Europe(developing only) in 2007 to that in 2011?
Offer a terse response. 0.97. What is the ratio of the Rating (1=low 6=high) of Europe(developing only) in 2007 to that in 2012?
Your answer should be compact. 0.95. What is the ratio of the Rating (1=low 6=high) in Afghanistan in 2007 to that in 2012?
Make the answer very short. 0.86. What is the ratio of the Rating (1=low 6=high) of Europe(developing only) in 2007 to that in 2013?
Make the answer very short. 0.95. What is the ratio of the Rating (1=low 6=high) of Latin America(all income levels) in 2007 to that in 2013?
Ensure brevity in your answer.  0.94. What is the ratio of the Rating (1=low 6=high) in Afghanistan in 2007 to that in 2013?
Offer a very short reply. 0.86. What is the ratio of the Rating (1=low 6=high) in Kenya in 2007 to that in 2013?
Your response must be concise. 0.88. What is the ratio of the Rating (1=low 6=high) in Europe(developing only) in 2007 to that in 2014?
Offer a very short reply. 0.97. What is the ratio of the Rating (1=low 6=high) of Latin America(all income levels) in 2007 to that in 2014?
Make the answer very short. 0.94. What is the ratio of the Rating (1=low 6=high) in Europe(developing only) in 2008 to that in 2009?
Make the answer very short. 1.04. What is the ratio of the Rating (1=low 6=high) in Latin America(all income levels) in 2008 to that in 2009?
Ensure brevity in your answer.  1.01. What is the ratio of the Rating (1=low 6=high) in Kenya in 2008 to that in 2009?
Offer a terse response. 0.88. What is the ratio of the Rating (1=low 6=high) of Europe(developing only) in 2008 to that in 2010?
Offer a terse response. 1.04. What is the ratio of the Rating (1=low 6=high) of Latin America(all income levels) in 2008 to that in 2010?
Your answer should be very brief. 1. What is the ratio of the Rating (1=low 6=high) in Europe(developing only) in 2008 to that in 2011?
Provide a short and direct response. 1. What is the ratio of the Rating (1=low 6=high) in Latin America(all income levels) in 2008 to that in 2011?
Ensure brevity in your answer.  1. What is the ratio of the Rating (1=low 6=high) of Afghanistan in 2008 to that in 2011?
Make the answer very short. 0.86. What is the ratio of the Rating (1=low 6=high) of Kenya in 2008 to that in 2011?
Give a very brief answer. 0.88. What is the ratio of the Rating (1=low 6=high) in Europe(developing only) in 2008 to that in 2012?
Make the answer very short. 0.98. What is the ratio of the Rating (1=low 6=high) in Latin America(all income levels) in 2008 to that in 2012?
Provide a short and direct response. 0.99. What is the ratio of the Rating (1=low 6=high) of Kenya in 2008 to that in 2012?
Your response must be concise. 0.88. What is the ratio of the Rating (1=low 6=high) in Europe(developing only) in 2008 to that in 2013?
Make the answer very short. 0.98. What is the ratio of the Rating (1=low 6=high) in Latin America(all income levels) in 2008 to that in 2013?
Offer a very short reply. 0.96. What is the ratio of the Rating (1=low 6=high) in Kenya in 2008 to that in 2013?
Offer a terse response. 0.88. What is the ratio of the Rating (1=low 6=high) in Europe(developing only) in 2008 to that in 2014?
Your response must be concise. 1. What is the ratio of the Rating (1=low 6=high) of Latin America(all income levels) in 2008 to that in 2014?
Offer a very short reply. 0.96. What is the ratio of the Rating (1=low 6=high) in Kenya in 2008 to that in 2014?
Your answer should be very brief. 0.88. What is the ratio of the Rating (1=low 6=high) of Kenya in 2009 to that in 2010?
Your answer should be very brief. 1. What is the ratio of the Rating (1=low 6=high) of Europe(developing only) in 2009 to that in 2011?
Provide a short and direct response. 0.96. What is the ratio of the Rating (1=low 6=high) of Europe(developing only) in 2009 to that in 2012?
Your answer should be very brief. 0.95. What is the ratio of the Rating (1=low 6=high) in Latin America(all income levels) in 2009 to that in 2012?
Offer a very short reply. 0.97. What is the ratio of the Rating (1=low 6=high) in Afghanistan in 2009 to that in 2012?
Offer a very short reply. 0.86. What is the ratio of the Rating (1=low 6=high) of Kenya in 2009 to that in 2012?
Give a very brief answer. 1. What is the ratio of the Rating (1=low 6=high) in Europe(developing only) in 2009 to that in 2013?
Offer a terse response. 0.95. What is the ratio of the Rating (1=low 6=high) in Latin America(all income levels) in 2009 to that in 2013?
Your response must be concise. 0.94. What is the ratio of the Rating (1=low 6=high) in Europe(developing only) in 2009 to that in 2014?
Offer a terse response. 0.96. What is the ratio of the Rating (1=low 6=high) of Latin America(all income levels) in 2009 to that in 2014?
Keep it short and to the point. 0.94. What is the ratio of the Rating (1=low 6=high) in Afghanistan in 2009 to that in 2014?
Make the answer very short. 0.86. What is the ratio of the Rating (1=low 6=high) of Kenya in 2009 to that in 2014?
Ensure brevity in your answer.  1. What is the ratio of the Rating (1=low 6=high) in Europe(developing only) in 2010 to that in 2011?
Ensure brevity in your answer.  0.96. What is the ratio of the Rating (1=low 6=high) of Latin America(all income levels) in 2010 to that in 2011?
Ensure brevity in your answer.  1. What is the ratio of the Rating (1=low 6=high) in Kenya in 2010 to that in 2011?
Provide a succinct answer. 1. What is the ratio of the Rating (1=low 6=high) in Europe(developing only) in 2010 to that in 2012?
Give a very brief answer. 0.95. What is the ratio of the Rating (1=low 6=high) in Latin America(all income levels) in 2010 to that in 2012?
Offer a terse response. 0.99. What is the ratio of the Rating (1=low 6=high) in Europe(developing only) in 2010 to that in 2013?
Ensure brevity in your answer.  0.95. What is the ratio of the Rating (1=low 6=high) of Latin America(all income levels) in 2010 to that in 2013?
Give a very brief answer. 0.96. What is the ratio of the Rating (1=low 6=high) of Afghanistan in 2010 to that in 2013?
Offer a very short reply. 0.86. What is the ratio of the Rating (1=low 6=high) in Europe(developing only) in 2010 to that in 2014?
Offer a very short reply. 0.96. What is the ratio of the Rating (1=low 6=high) in Latin America(all income levels) in 2010 to that in 2014?
Provide a short and direct response. 0.96. What is the ratio of the Rating (1=low 6=high) of Kenya in 2010 to that in 2014?
Your response must be concise. 1. What is the ratio of the Rating (1=low 6=high) in Europe(developing only) in 2011 to that in 2012?
Your answer should be compact. 0.98. What is the ratio of the Rating (1=low 6=high) of Latin America(all income levels) in 2011 to that in 2012?
Offer a terse response. 0.99. What is the ratio of the Rating (1=low 6=high) of Europe(developing only) in 2011 to that in 2013?
Offer a terse response. 0.98. What is the ratio of the Rating (1=low 6=high) of Latin America(all income levels) in 2011 to that in 2013?
Ensure brevity in your answer.  0.96. What is the ratio of the Rating (1=low 6=high) in Kenya in 2011 to that in 2013?
Provide a succinct answer. 1. What is the ratio of the Rating (1=low 6=high) of Europe(developing only) in 2011 to that in 2014?
Your answer should be very brief. 1. What is the ratio of the Rating (1=low 6=high) of Latin America(all income levels) in 2011 to that in 2014?
Offer a terse response. 0.96. What is the ratio of the Rating (1=low 6=high) in Afghanistan in 2011 to that in 2014?
Ensure brevity in your answer.  1. What is the ratio of the Rating (1=low 6=high) in Kenya in 2011 to that in 2014?
Your answer should be compact. 1. What is the ratio of the Rating (1=low 6=high) of Europe(developing only) in 2012 to that in 2013?
Provide a succinct answer. 1. What is the ratio of the Rating (1=low 6=high) in Latin America(all income levels) in 2012 to that in 2013?
Give a very brief answer. 0.97. What is the ratio of the Rating (1=low 6=high) of Europe(developing only) in 2012 to that in 2014?
Your answer should be very brief. 1.02. What is the ratio of the Rating (1=low 6=high) in Latin America(all income levels) in 2012 to that in 2014?
Give a very brief answer. 0.97. What is the ratio of the Rating (1=low 6=high) in Afghanistan in 2012 to that in 2014?
Keep it short and to the point. 1. What is the ratio of the Rating (1=low 6=high) of Europe(developing only) in 2013 to that in 2014?
Offer a very short reply. 1.02. What is the ratio of the Rating (1=low 6=high) in Latin America(all income levels) in 2013 to that in 2014?
Offer a very short reply. 1. What is the ratio of the Rating (1=low 6=high) in Kenya in 2013 to that in 2014?
Offer a terse response. 1. What is the difference between the highest and the second highest Rating (1=low 6=high) of Afghanistan?
Your answer should be very brief. 0. What is the difference between the highest and the second highest Rating (1=low 6=high) of Kenya?
Offer a terse response. 0. What is the difference between the highest and the lowest Rating (1=low 6=high) in Europe(developing only)?
Keep it short and to the point. 0.21. What is the difference between the highest and the lowest Rating (1=low 6=high) in Latin America(all income levels)?
Offer a terse response. 0.22. What is the difference between the highest and the lowest Rating (1=low 6=high) in Afghanistan?
Make the answer very short. 0.5. 